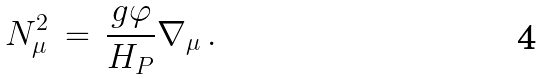Convert formula to latex. <formula><loc_0><loc_0><loc_500><loc_500>N _ { \mu } ^ { 2 } \, = \, \frac { g \varphi } { H _ { P } } \nabla _ { \mu } \, .</formula> 